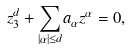<formula> <loc_0><loc_0><loc_500><loc_500>z _ { 3 } ^ { d } + \underset { \left | \alpha \right | \leq d } { \sum } a _ { \alpha } z ^ { \alpha } = 0 ,</formula> 